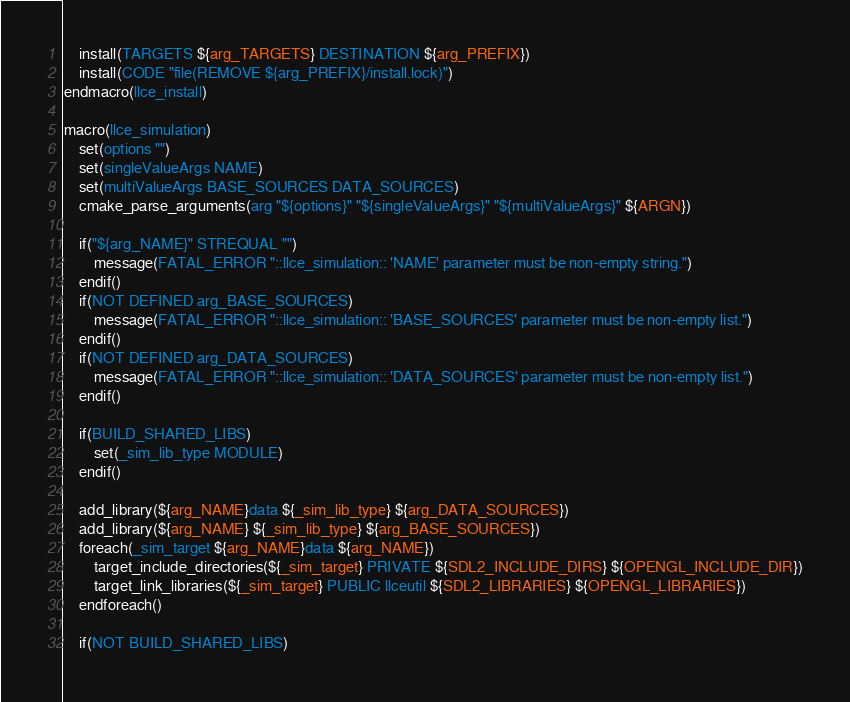<code> <loc_0><loc_0><loc_500><loc_500><_CMake_>    install(TARGETS ${arg_TARGETS} DESTINATION ${arg_PREFIX})
    install(CODE "file(REMOVE ${arg_PREFIX}/install.lock)")
endmacro(llce_install)

macro(llce_simulation)
    set(options "")
    set(singleValueArgs NAME)
    set(multiValueArgs BASE_SOURCES DATA_SOURCES)
    cmake_parse_arguments(arg "${options}" "${singleValueArgs}" "${multiValueArgs}" ${ARGN})

    if("${arg_NAME}" STREQUAL "")
        message(FATAL_ERROR "::llce_simulation:: 'NAME' parameter must be non-empty string.")
    endif()
    if(NOT DEFINED arg_BASE_SOURCES)
        message(FATAL_ERROR "::llce_simulation:: 'BASE_SOURCES' parameter must be non-empty list.")
    endif()
    if(NOT DEFINED arg_DATA_SOURCES)
        message(FATAL_ERROR "::llce_simulation:: 'DATA_SOURCES' parameter must be non-empty list.")
    endif()

    if(BUILD_SHARED_LIBS)
        set(_sim_lib_type MODULE)
    endif()

    add_library(${arg_NAME}data ${_sim_lib_type} ${arg_DATA_SOURCES})
    add_library(${arg_NAME} ${_sim_lib_type} ${arg_BASE_SOURCES})
    foreach(_sim_target ${arg_NAME}data ${arg_NAME})
        target_include_directories(${_sim_target} PRIVATE ${SDL2_INCLUDE_DIRS} ${OPENGL_INCLUDE_DIR})
        target_link_libraries(${_sim_target} PUBLIC llceutil ${SDL2_LIBRARIES} ${OPENGL_LIBRARIES})
    endforeach()

    if(NOT BUILD_SHARED_LIBS)</code> 